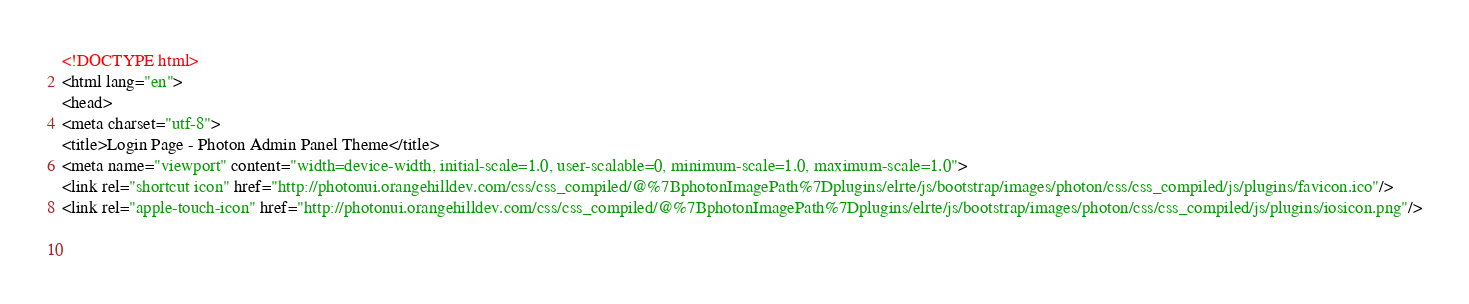Convert code to text. <code><loc_0><loc_0><loc_500><loc_500><_HTML_><!DOCTYPE html>
<html lang="en">
<head>
<meta charset="utf-8">
<title>Login Page - Photon Admin Panel Theme</title>
<meta name="viewport" content="width=device-width, initial-scale=1.0, user-scalable=0, minimum-scale=1.0, maximum-scale=1.0">
<link rel="shortcut icon" href="http://photonui.orangehilldev.com/css/css_compiled/@%7BphotonImagePath%7Dplugins/elrte/js/bootstrap/images/photon/css/css_compiled/js/plugins/favicon.ico"/>
<link rel="apple-touch-icon" href="http://photonui.orangehilldev.com/css/css_compiled/@%7BphotonImagePath%7Dplugins/elrte/js/bootstrap/images/photon/css/css_compiled/js/plugins/iosicon.png"/>
 
   </code> 